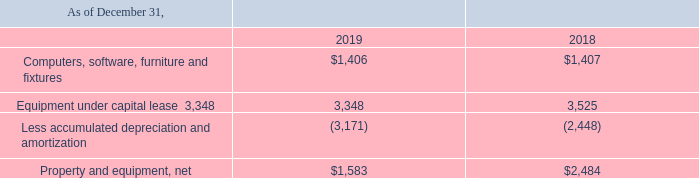4. Property and Equipment
Property and equipment consist of the following (in thousands):
Depreciation and amortization expense was $0.9 million and $1.0 million for the years ended December 31, 2019 and 2018, respectively.
How much were the depreciation and amortization expenses for the years ended December 31, 2018, and 2019, respectively? $1.0 million, $0.9 million. What is the net value of property and equipment as of December 31, 2019, and 2018, respectively? 
Answer scale should be: thousand. $1,583, $2,484. What is the value of equipment under capital lease as of December 31, 2019?
Answer scale should be: thousand. 3,348. What is the ratio of depreciation and amortization expense for the year 2018 to 2019? 1/0.9 
Answer: 1.11. What is the percentage change in computers, software, furniture and fixtures between 2018 and 2019?
Answer scale should be: percent. ($1,406-$1,407)/$1,407 
Answer: -0.07. What is the percentage change in the net value of property and equipment between 2018 and 2019?
Answer scale should be: percent. ($1,583-$2,484)/$2,484 
Answer: -36.27. 